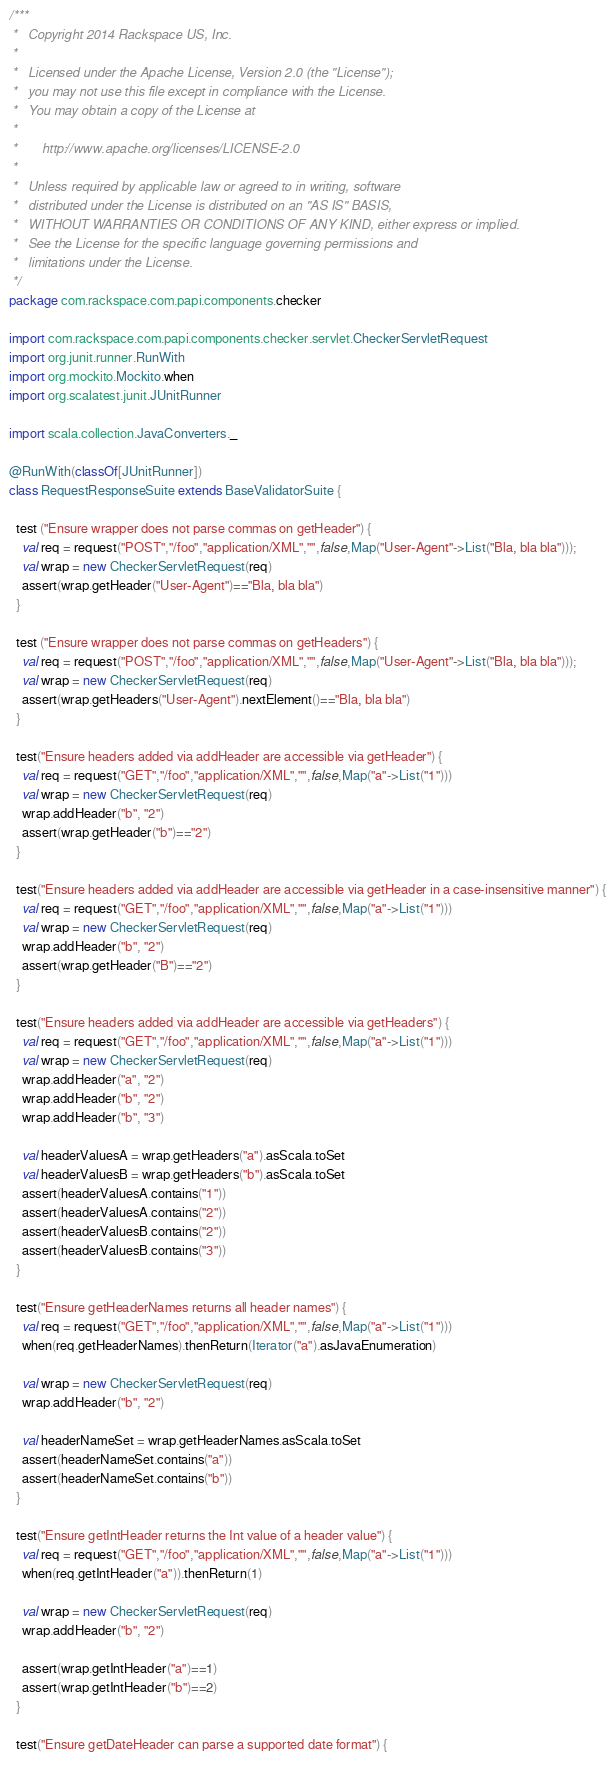Convert code to text. <code><loc_0><loc_0><loc_500><loc_500><_Scala_>/***
 *   Copyright 2014 Rackspace US, Inc.
 *
 *   Licensed under the Apache License, Version 2.0 (the "License");
 *   you may not use this file except in compliance with the License.
 *   You may obtain a copy of the License at
 *
 *       http://www.apache.org/licenses/LICENSE-2.0
 *
 *   Unless required by applicable law or agreed to in writing, software
 *   distributed under the License is distributed on an "AS IS" BASIS,
 *   WITHOUT WARRANTIES OR CONDITIONS OF ANY KIND, either express or implied.
 *   See the License for the specific language governing permissions and
 *   limitations under the License.
 */
package com.rackspace.com.papi.components.checker

import com.rackspace.com.papi.components.checker.servlet.CheckerServletRequest
import org.junit.runner.RunWith
import org.mockito.Mockito.when
import org.scalatest.junit.JUnitRunner

import scala.collection.JavaConverters._

@RunWith(classOf[JUnitRunner])
class RequestResponseSuite extends BaseValidatorSuite {

  test ("Ensure wrapper does not parse commas on getHeader") {
    val req = request("POST","/foo","application/XML","",false,Map("User-Agent"->List("Bla, bla bla")));
    val wrap = new CheckerServletRequest(req)
    assert(wrap.getHeader("User-Agent")=="Bla, bla bla")
  }

  test ("Ensure wrapper does not parse commas on getHeaders") {
    val req = request("POST","/foo","application/XML","",false,Map("User-Agent"->List("Bla, bla bla")));
    val wrap = new CheckerServletRequest(req)
    assert(wrap.getHeaders("User-Agent").nextElement()=="Bla, bla bla")
  }

  test("Ensure headers added via addHeader are accessible via getHeader") {
    val req = request("GET","/foo","application/XML","",false,Map("a"->List("1")))
    val wrap = new CheckerServletRequest(req)
    wrap.addHeader("b", "2")
    assert(wrap.getHeader("b")=="2")
  }

  test("Ensure headers added via addHeader are accessible via getHeader in a case-insensitive manner") {
    val req = request("GET","/foo","application/XML","",false,Map("a"->List("1")))
    val wrap = new CheckerServletRequest(req)
    wrap.addHeader("b", "2")
    assert(wrap.getHeader("B")=="2")
  }

  test("Ensure headers added via addHeader are accessible via getHeaders") {
    val req = request("GET","/foo","application/XML","",false,Map("a"->List("1")))
    val wrap = new CheckerServletRequest(req)
    wrap.addHeader("a", "2")
    wrap.addHeader("b", "2")
    wrap.addHeader("b", "3")

    val headerValuesA = wrap.getHeaders("a").asScala.toSet
    val headerValuesB = wrap.getHeaders("b").asScala.toSet
    assert(headerValuesA.contains("1"))
    assert(headerValuesA.contains("2"))
    assert(headerValuesB.contains("2"))
    assert(headerValuesB.contains("3"))
  }

  test("Ensure getHeaderNames returns all header names") {
    val req = request("GET","/foo","application/XML","",false,Map("a"->List("1")))
    when(req.getHeaderNames).thenReturn(Iterator("a").asJavaEnumeration)

    val wrap = new CheckerServletRequest(req)
    wrap.addHeader("b", "2")

    val headerNameSet = wrap.getHeaderNames.asScala.toSet
    assert(headerNameSet.contains("a"))
    assert(headerNameSet.contains("b"))
  }

  test("Ensure getIntHeader returns the Int value of a header value") {
    val req = request("GET","/foo","application/XML","",false,Map("a"->List("1")))
    when(req.getIntHeader("a")).thenReturn(1)

    val wrap = new CheckerServletRequest(req)
    wrap.addHeader("b", "2")

    assert(wrap.getIntHeader("a")==1)
    assert(wrap.getIntHeader("b")==2)
  }

  test("Ensure getDateHeader can parse a supported date format") {</code> 